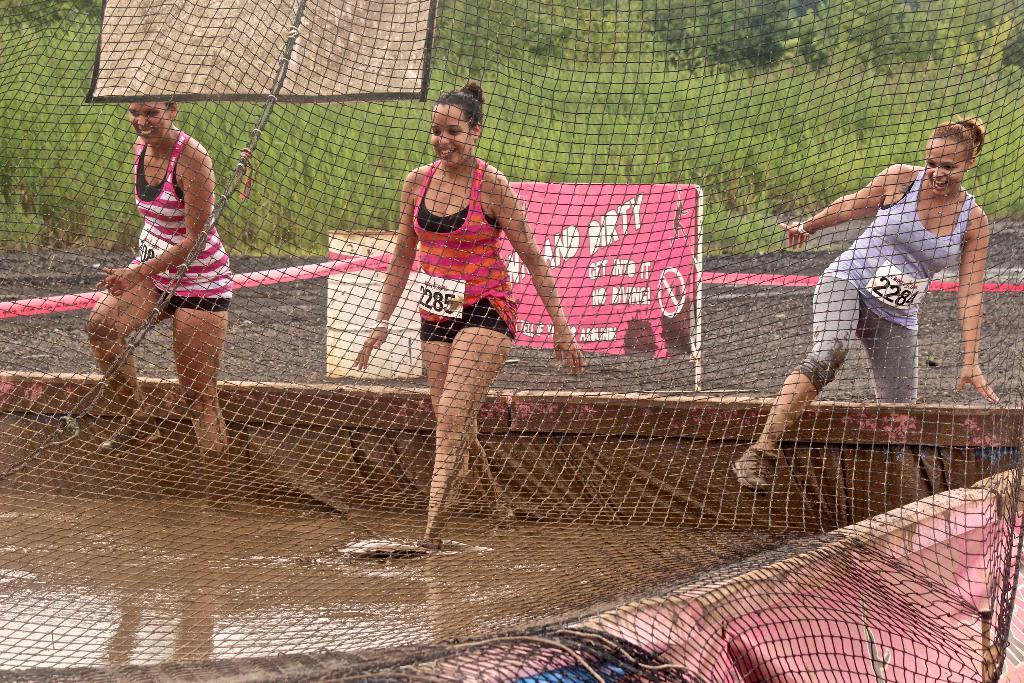<image>
Provide a brief description of the given image. Three women are stepping into a vat of muddy water in front of a sign saying not to dive in. 